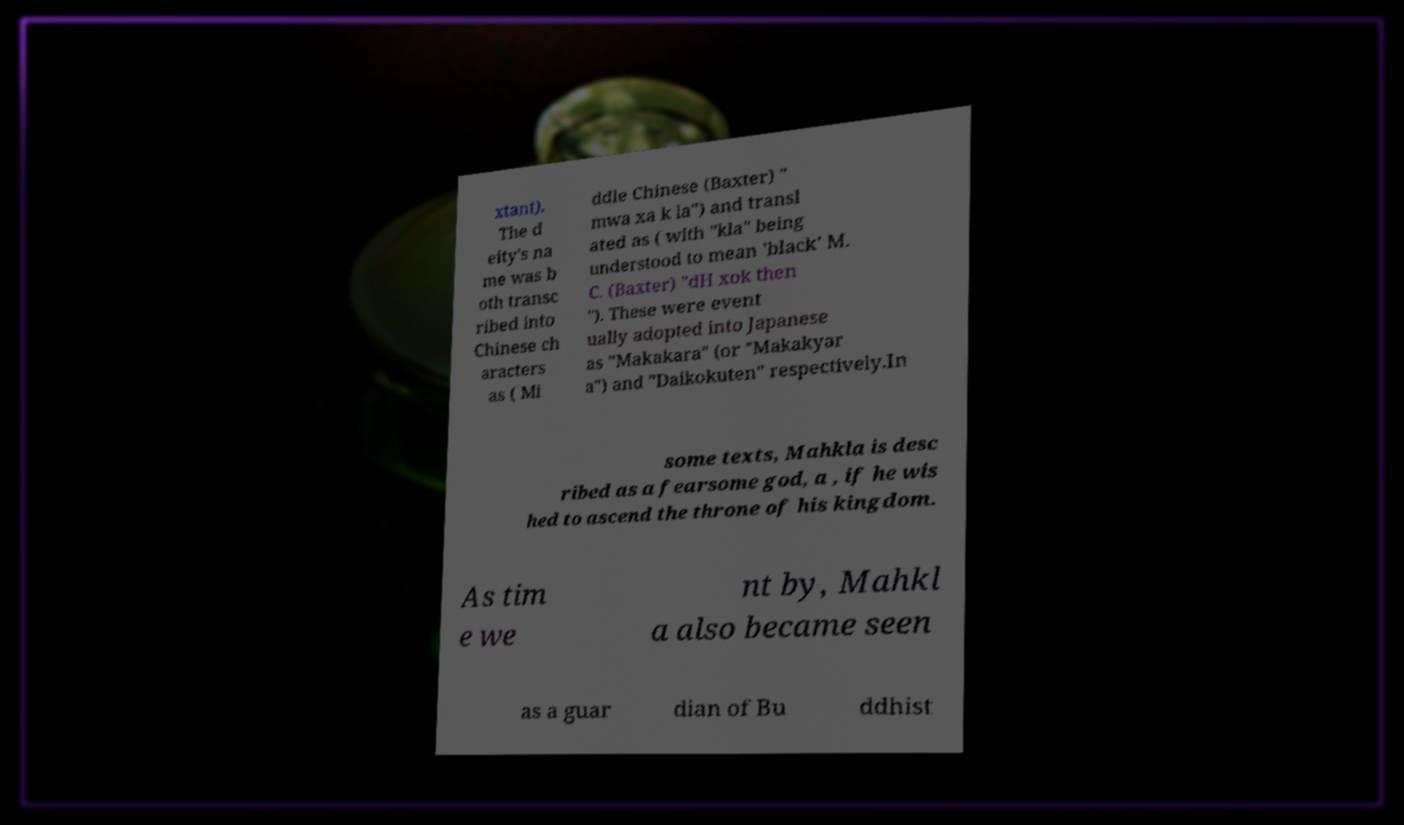Please identify and transcribe the text found in this image. xtant). The d eity's na me was b oth transc ribed into Chinese ch aracters as ( Mi ddle Chinese (Baxter) " mwa xa k la") and transl ated as ( with "kla" being understood to mean 'black' M. C. (Baxter) "dH xok then "). These were event ually adopted into Japanese as "Makakara" (or "Makakyar a") and "Daikokuten" respectively.In some texts, Mahkla is desc ribed as a fearsome god, a , if he wis hed to ascend the throne of his kingdom. As tim e we nt by, Mahkl a also became seen as a guar dian of Bu ddhist 